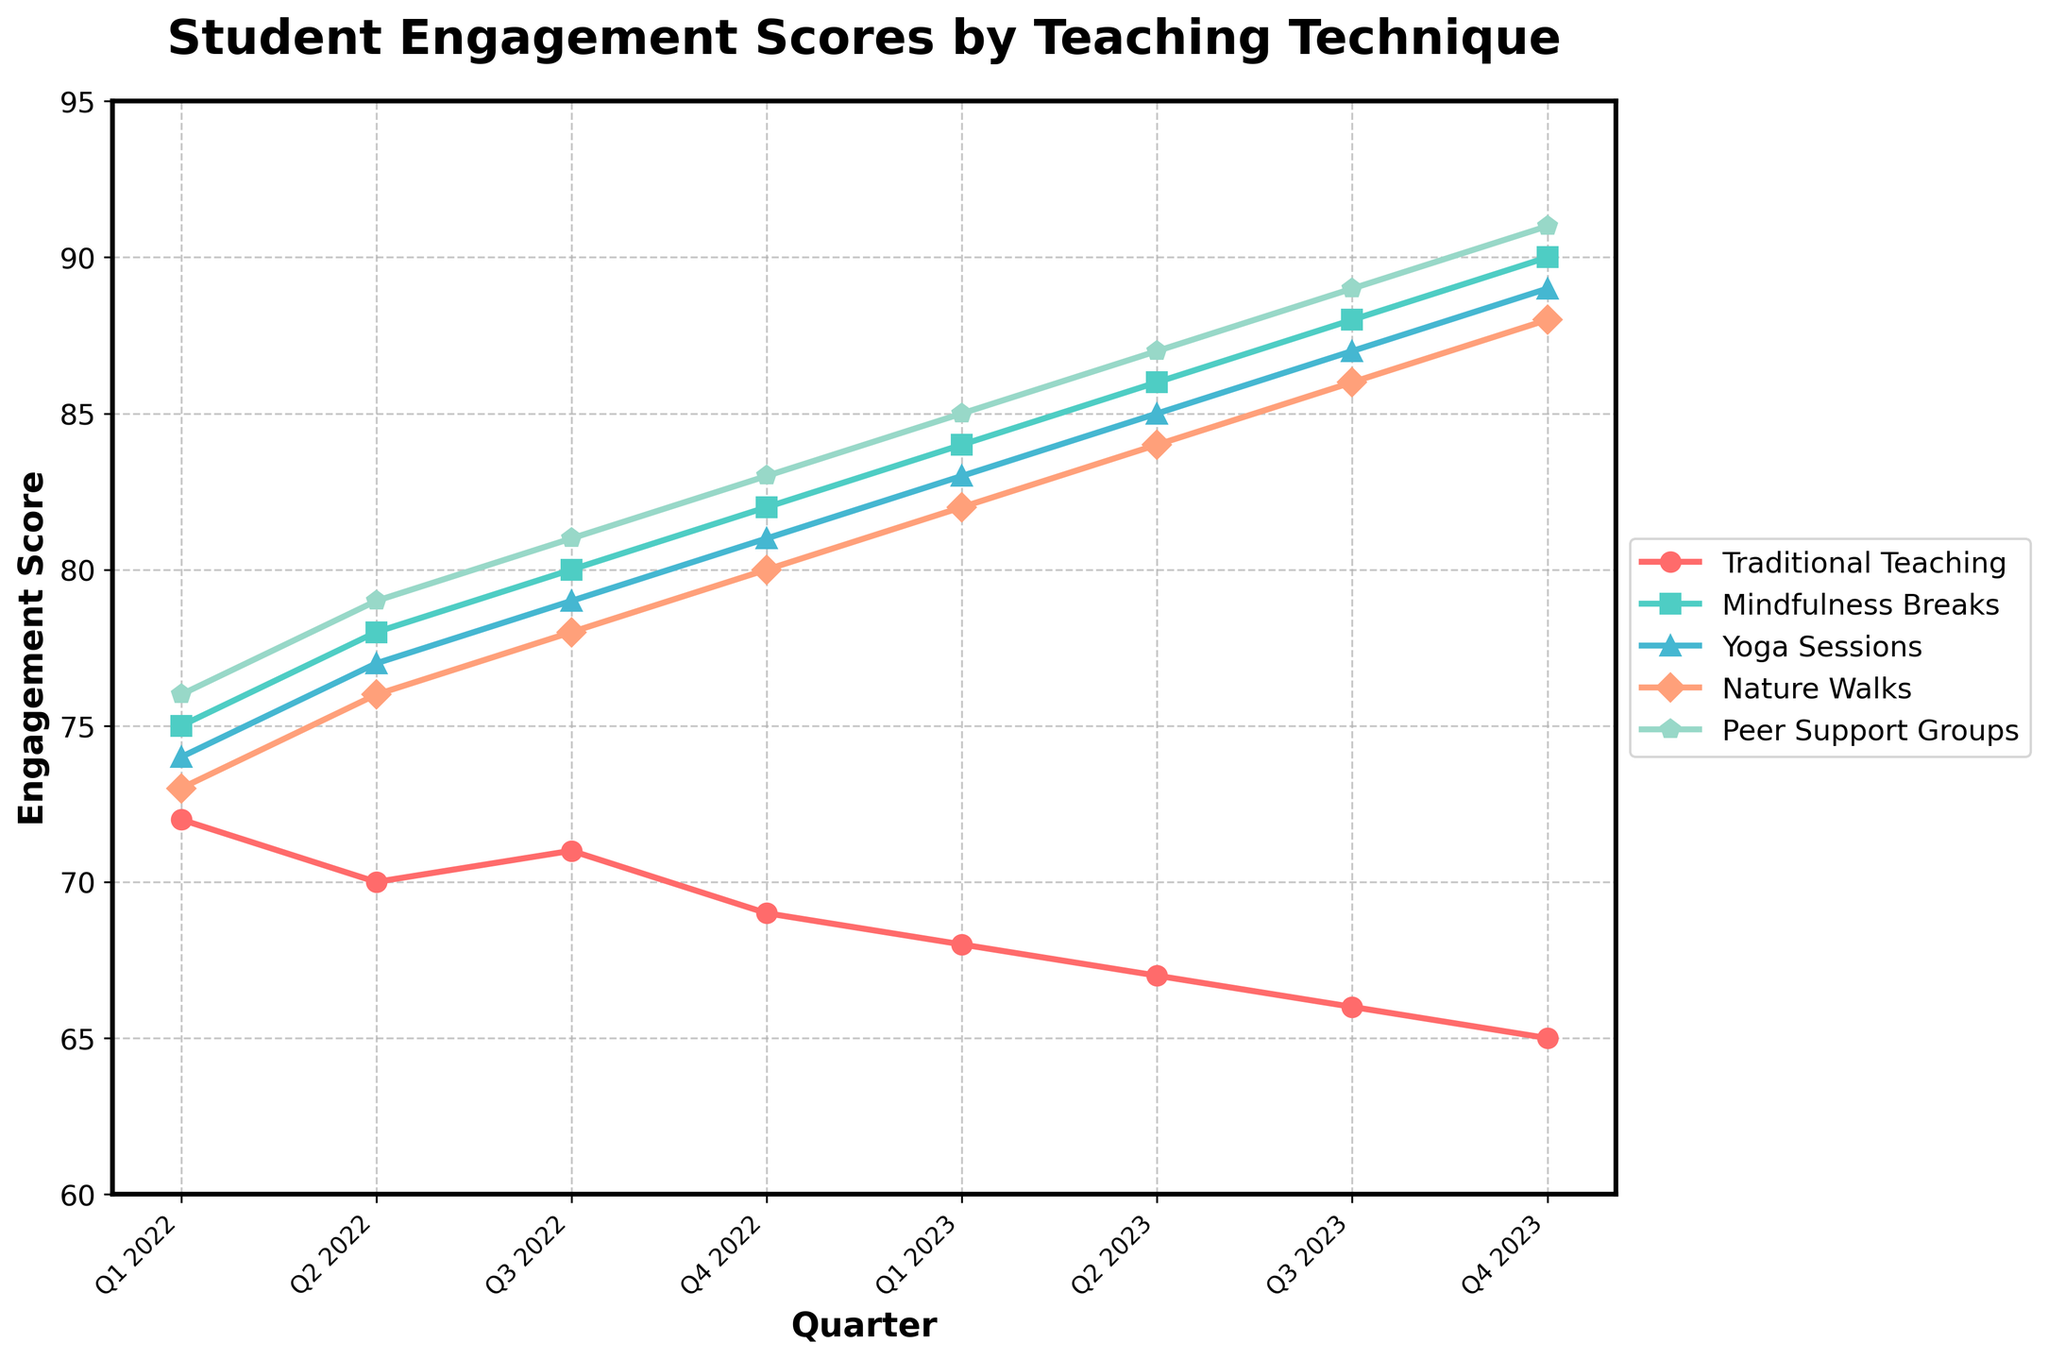Which technique shows the highest student engagement score in Q4 2023? Look at the Q4 2023 data point for each technique. The highest value is for the "Peer Support Groups" technique with a score of 91.
Answer: Peer Support Groups Which quarter shows the lowest student engagement score for Traditional Teaching? Examine the Traditional Teaching scores across all quarters and find the minimum value. Q4 2023 has the lowest score of 65.
Answer: Q4 2023 What is the average student engagement score for Yoga Sessions in 2022? Find the Yoga Sessions scores for Q1 2022 to Q4 2022: (74 + 77 + 79 + 81). Sum them up and divide by 4 to get the average: (74 + 77 + 79 + 81) / 4 = 77.75.
Answer: 77.75 By how much did the student engagement score for Mindfulness Breaks increase from Q1 2022 to Q4 2023? Subtract the Q1 2022 score from the Q4 2023 score for Mindfulness Breaks: 90 - 75 = 15.
Answer: 15 Which stress-reduction technique consistently showed an increase in student engagement scores every quarter? Examine each technique's scores from Q1 2022 to Q4 2023. The techniques that show a consistent increase are "Mindfulness Breaks" and "Peer Support Groups".
Answer: Mindfulness Breaks, Peer Support Groups How much higher is the engagement score for Nature Walks compared to Traditional Teaching in Q3 2023? Subtract the Traditional Teaching score from the Nature Walks score in Q3 2023: 86 - 66 = 20.
Answer: 20 What is the total increase in student engagement score for Peer Support Groups from Q1 2022 to Q4 2023? Subtract the Q1 2022 score from the Q4 2023 score for Peer Support Groups: 91 - 76 = 15.
Answer: 15 Which technique had the smallest improvement in student engagement score from Q1 2022 to Q4 2023? Calculate the difference between Q1 2022 and Q4 2023 scores for each technique. The smallest difference is for Traditional Teaching: 65 - 72 = -7.
Answer: Traditional Teaching What is the combined student engagement score of all techniques in Q2 2023? Add the scores of all techniques in Q2 2023: 67 (Traditional Teaching) + 86 (Mindfulness Breaks) + 85 (Yoga Sessions) + 84 (Nature Walks) + 87 (Peer Support Groups) = 409.
Answer: 409 